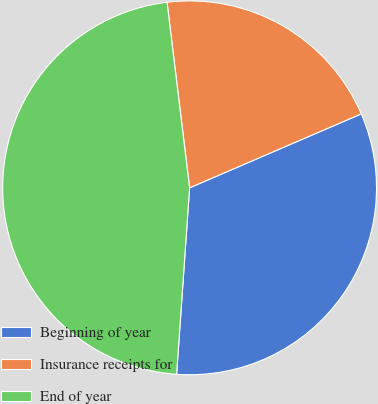<chart> <loc_0><loc_0><loc_500><loc_500><pie_chart><fcel>Beginning of year<fcel>Insurance receipts for<fcel>End of year<nl><fcel>32.58%<fcel>20.45%<fcel>46.97%<nl></chart> 